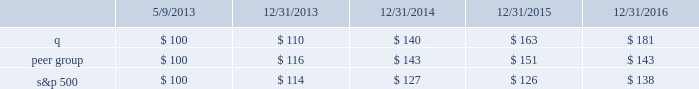Stock performance graph this performance graph shall not be deemed 201cfiled 201d for purposes of section 18 of the exchange act , or incorporated by reference into any filing of quintiles ims holdings , inc .
Under the exchange act or under the securities act , except as shall be expressly set forth by specific reference in such filing .
The following graph shows a comparison from may 9 , 2013 ( the date our common stock commenced trading on the nyse ) through december 31 , 2016 of the cumulative total return for our common stock , the standard & poor 2019s 500 stock index ( 201cs&p 500 201d ) and a select peer group .
The peer group consists of cerner corporation , charles river laboratories , inc. , dun & bradstreet corporation , equifax inc. , icon plc , ihs markit ltd. , inc research holdings , laboratory corporation of america holdings , nielsen n.v. , parexel international corporation , inc. , pra health sciences , inc. , thomson reuters corporation and verisk analytics , inc .
The companies in our peer group are publicly traded information services , information technology or contract research companies , and thus share similar business model characteristics to quintilesims , or provide services to similar customers as quintilesims .
Many of these companies are also used by our compensation committee for purposes of compensation benchmarking .
The graph assumes that $ 100 was invested in quintilesims , the s&p 500 and the peer group as of the close of market on may 9 , 2013 , assumes the reinvestments of dividends , if any .
The s&p 500 and our peer group are included for comparative purposes only .
They do not necessarily reflect management 2019s opinion that the s&p 500 and our peer group are an appropriate measure of the relative performance of the stock involved , and they are not intended to forecast or be indicative of possible future performance of our common stock .
S&p 500 quintilesims peer group .
Item 6 .
Selected financial data we have derived the following consolidated statements of income data for 2016 , 2015 and 2014 and consolidated balance sheet data as of december 31 , 2016 and 2015 from our audited consolidated financial .
What is the return on investment for s&p500 if the investment is sold at the end of year 2014? 
Computations: ((127 - 100) / 100)
Answer: 0.27. Stock performance graph this performance graph shall not be deemed 201cfiled 201d for purposes of section 18 of the exchange act , or incorporated by reference into any filing of quintiles ims holdings , inc .
Under the exchange act or under the securities act , except as shall be expressly set forth by specific reference in such filing .
The following graph shows a comparison from may 9 , 2013 ( the date our common stock commenced trading on the nyse ) through december 31 , 2016 of the cumulative total return for our common stock , the standard & poor 2019s 500 stock index ( 201cs&p 500 201d ) and a select peer group .
The peer group consists of cerner corporation , charles river laboratories , inc. , dun & bradstreet corporation , equifax inc. , icon plc , ihs markit ltd. , inc research holdings , laboratory corporation of america holdings , nielsen n.v. , parexel international corporation , inc. , pra health sciences , inc. , thomson reuters corporation and verisk analytics , inc .
The companies in our peer group are publicly traded information services , information technology or contract research companies , and thus share similar business model characteristics to quintilesims , or provide services to similar customers as quintilesims .
Many of these companies are also used by our compensation committee for purposes of compensation benchmarking .
The graph assumes that $ 100 was invested in quintilesims , the s&p 500 and the peer group as of the close of market on may 9 , 2013 , assumes the reinvestments of dividends , if any .
The s&p 500 and our peer group are included for comparative purposes only .
They do not necessarily reflect management 2019s opinion that the s&p 500 and our peer group are an appropriate measure of the relative performance of the stock involved , and they are not intended to forecast or be indicative of possible future performance of our common stock .
S&p 500 quintilesims peer group .
Item 6 .
Selected financial data we have derived the following consolidated statements of income data for 2016 , 2015 and 2014 and consolidated balance sheet data as of december 31 , 2016 and 2015 from our audited consolidated financial .
In 2013 what was the anticipated percentage growth in the stock performance for the peer group in 2014? 
Computations: ((143 - 100) / 100)
Answer: 0.43. 